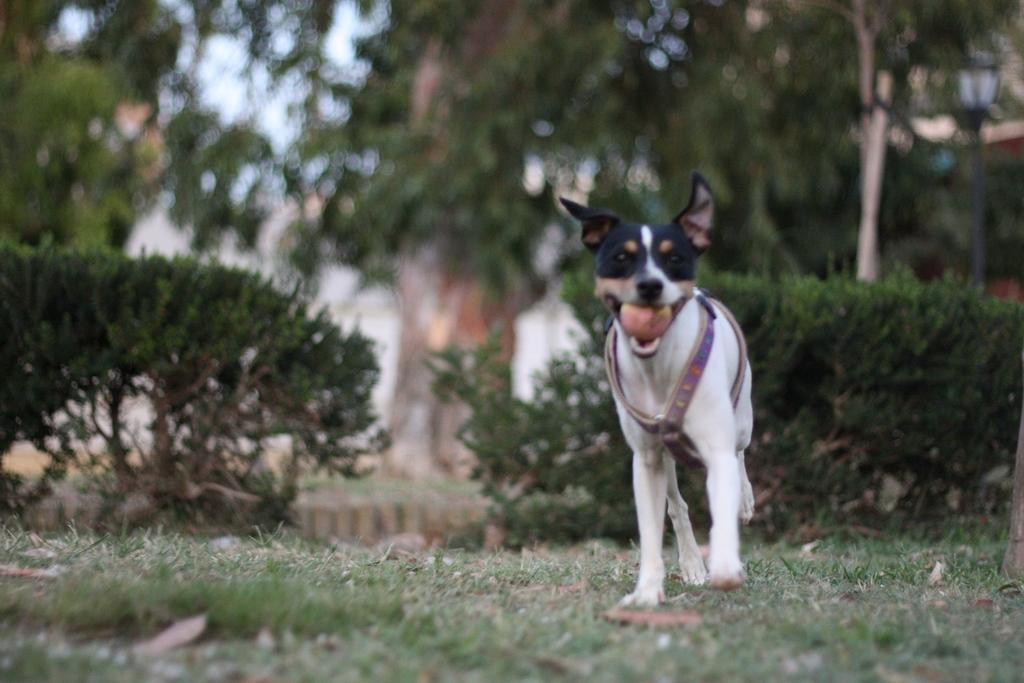How would you summarize this image in a sentence or two? This is dog, there are green color trees. 